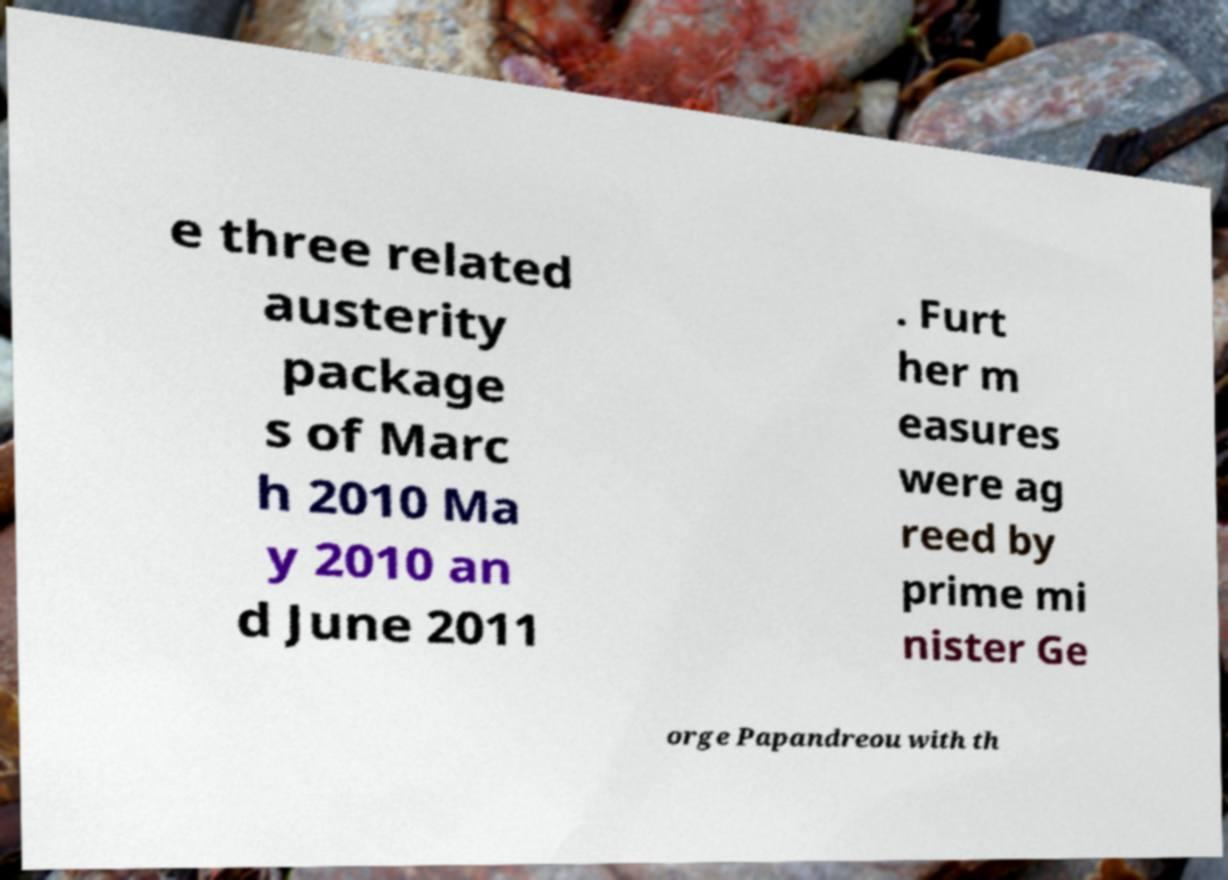Could you assist in decoding the text presented in this image and type it out clearly? e three related austerity package s of Marc h 2010 Ma y 2010 an d June 2011 . Furt her m easures were ag reed by prime mi nister Ge orge Papandreou with th 